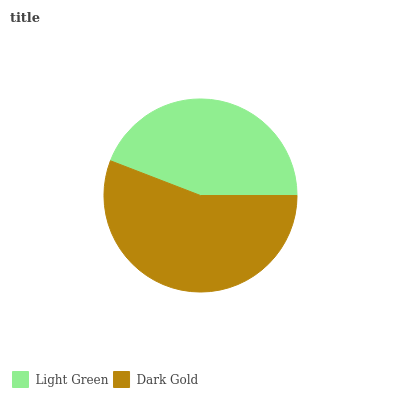Is Light Green the minimum?
Answer yes or no. Yes. Is Dark Gold the maximum?
Answer yes or no. Yes. Is Dark Gold the minimum?
Answer yes or no. No. Is Dark Gold greater than Light Green?
Answer yes or no. Yes. Is Light Green less than Dark Gold?
Answer yes or no. Yes. Is Light Green greater than Dark Gold?
Answer yes or no. No. Is Dark Gold less than Light Green?
Answer yes or no. No. Is Dark Gold the high median?
Answer yes or no. Yes. Is Light Green the low median?
Answer yes or no. Yes. Is Light Green the high median?
Answer yes or no. No. Is Dark Gold the low median?
Answer yes or no. No. 